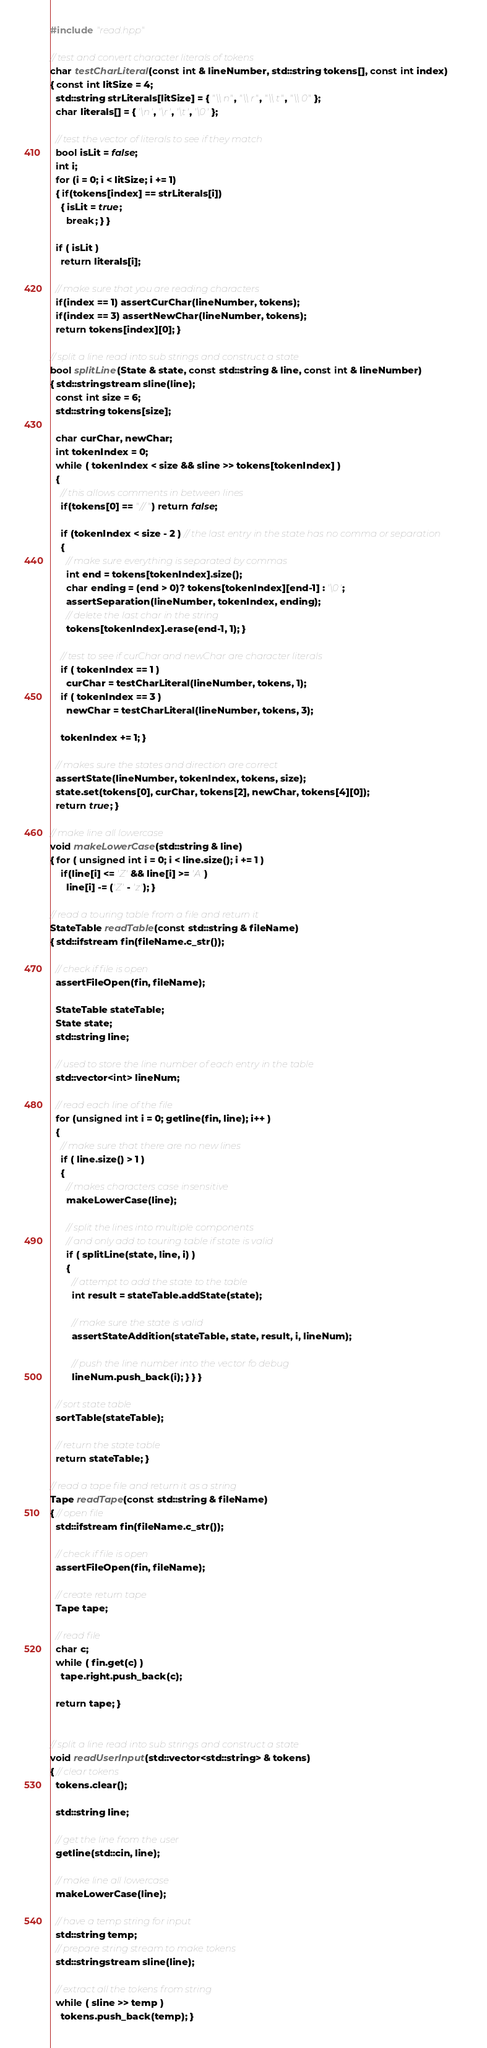Convert code to text. <code><loc_0><loc_0><loc_500><loc_500><_C++_>#include "read.hpp"

// test and convert character literals of tokens
char testCharLiteral(const int & lineNumber, std::string tokens[], const int index)
{ const int litSize = 4;
  std::string strLiterals[litSize] = { "\\n", "\\r", "\\t", "\\0" };
  char literals[] = { '\n', '\r', '\t', '\0' };

  // test the vector of literals to see if they match
  bool isLit = false;
  int i;
  for (i = 0; i < litSize; i += 1)
  { if(tokens[index] == strLiterals[i])
    { isLit = true;
      break; } }

  if ( isLit )
    return literals[i];

  // make sure that you are reading characters
  if(index == 1) assertCurChar(lineNumber, tokens);
  if(index == 3) assertNewChar(lineNumber, tokens);
  return tokens[index][0]; }

// split a line read into sub strings and construct a state
bool splitLine(State & state, const std::string & line, const int & lineNumber)
{ std::stringstream sline(line);
  const int size = 6;
  std::string tokens[size];

  char curChar, newChar;
  int tokenIndex = 0;
  while ( tokenIndex < size && sline >> tokens[tokenIndex] )
  {
    // this allows comments in between lines
    if(tokens[0] == "//") return false;

    if (tokenIndex < size - 2 ) // the last entry in the state has no comma or separation
    {
      // make sure everything is separated by commas
      int end = tokens[tokenIndex].size();
      char ending = (end > 0)? tokens[tokenIndex][end-1] : '\0';
      assertSeparation(lineNumber, tokenIndex, ending);
      // delete the last char in the string
      tokens[tokenIndex].erase(end-1, 1); }

    // test to see if curChar and newChar are character literals
    if ( tokenIndex == 1 )
      curChar = testCharLiteral(lineNumber, tokens, 1);
    if ( tokenIndex == 3 )
      newChar = testCharLiteral(lineNumber, tokens, 3);

    tokenIndex += 1; }

  // makes sure the states and direction are correct
  assertState(lineNumber, tokenIndex, tokens, size);
  state.set(tokens[0], curChar, tokens[2], newChar, tokens[4][0]);
  return true; }

// make line all lowercase
void makeLowerCase(std::string & line)
{ for ( unsigned int i = 0; i < line.size(); i += 1 )
    if(line[i] <= 'Z' && line[i] >= 'A')
      line[i] -= ('Z' - 'z'); }

// read a touring table from a file and return it
StateTable readTable(const std::string & fileName)
{ std::ifstream fin(fileName.c_str());

  // check if file is open
  assertFileOpen(fin, fileName);

  StateTable stateTable;
  State state;
  std::string line;

  // used to store the line number of each entry in the table
  std::vector<int> lineNum;

  // read each line of the file
  for (unsigned int i = 0; getline(fin, line); i++ )
  {
    // make sure that there are no new lines
    if ( line.size() > 1 )
    {
      // makes characters case insensitive
      makeLowerCase(line);

      // split the lines into multiple components
      // and only add to touring table if state is valid
      if ( splitLine(state, line, i) )
      {
        // attempt to add the state to the table
        int result = stateTable.addState(state);

        // make sure the state is valid
        assertStateAddition(stateTable, state, result, i, lineNum);

        // push the line number into the vector fo debug
        lineNum.push_back(i); } } }

  // sort state table
  sortTable(stateTable);

  // return the state table
  return stateTable; }

// read a tape file and return it as a string
Tape readTape(const std::string & fileName)
{ // open file
  std::ifstream fin(fileName.c_str());

  // check if file is open
  assertFileOpen(fin, fileName);

  // create return tape
  Tape tape;

  // read file
  char c;
  while ( fin.get(c) )
    tape.right.push_back(c);

  return tape; }


// split a line read into sub strings and construct a state
void readUserInput(std::vector<std::string> & tokens)
{ // clear tokens 
  tokens.clear();

  std::string line;

  // get the line from the user
  getline(std::cin, line);

  // make line all lowercase
  makeLowerCase(line);

  // have a temp string for input
  std::string temp;
  // prepare string stream to make tokens
  std::stringstream sline(line);

  // extract all the tokens from string
  while ( sline >> temp )
    tokens.push_back(temp); }

</code> 